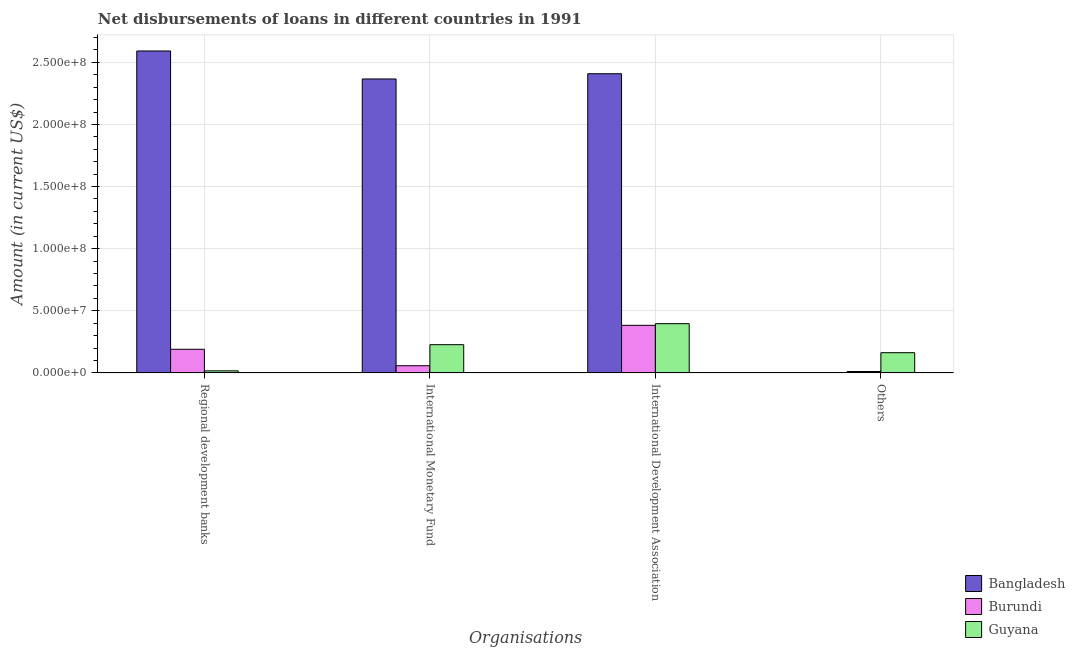Are the number of bars per tick equal to the number of legend labels?
Provide a succinct answer. No. How many bars are there on the 2nd tick from the left?
Provide a short and direct response. 3. How many bars are there on the 3rd tick from the right?
Ensure brevity in your answer.  3. What is the label of the 4th group of bars from the left?
Keep it short and to the point. Others. What is the amount of loan disimbursed by international development association in Bangladesh?
Make the answer very short. 2.41e+08. Across all countries, what is the maximum amount of loan disimbursed by international monetary fund?
Ensure brevity in your answer.  2.37e+08. Across all countries, what is the minimum amount of loan disimbursed by other organisations?
Give a very brief answer. 0. In which country was the amount of loan disimbursed by international monetary fund maximum?
Provide a short and direct response. Bangladesh. What is the total amount of loan disimbursed by regional development banks in the graph?
Provide a short and direct response. 2.80e+08. What is the difference between the amount of loan disimbursed by international development association in Bangladesh and that in Guyana?
Offer a very short reply. 2.01e+08. What is the difference between the amount of loan disimbursed by regional development banks in Guyana and the amount of loan disimbursed by other organisations in Burundi?
Keep it short and to the point. 5.36e+05. What is the average amount of loan disimbursed by other organisations per country?
Your answer should be compact. 5.78e+06. What is the difference between the amount of loan disimbursed by international development association and amount of loan disimbursed by other organisations in Burundi?
Your answer should be compact. 3.72e+07. In how many countries, is the amount of loan disimbursed by other organisations greater than 70000000 US$?
Offer a terse response. 0. What is the ratio of the amount of loan disimbursed by international development association in Bangladesh to that in Burundi?
Provide a short and direct response. 6.29. Is the amount of loan disimbursed by international development association in Burundi less than that in Bangladesh?
Give a very brief answer. Yes. Is the difference between the amount of loan disimbursed by regional development banks in Burundi and Guyana greater than the difference between the amount of loan disimbursed by international development association in Burundi and Guyana?
Your answer should be very brief. Yes. What is the difference between the highest and the second highest amount of loan disimbursed by international development association?
Ensure brevity in your answer.  2.01e+08. What is the difference between the highest and the lowest amount of loan disimbursed by other organisations?
Ensure brevity in your answer.  1.62e+07. In how many countries, is the amount of loan disimbursed by other organisations greater than the average amount of loan disimbursed by other organisations taken over all countries?
Give a very brief answer. 1. Is the sum of the amount of loan disimbursed by international development association in Guyana and Burundi greater than the maximum amount of loan disimbursed by other organisations across all countries?
Ensure brevity in your answer.  Yes. Is it the case that in every country, the sum of the amount of loan disimbursed by international development association and amount of loan disimbursed by international monetary fund is greater than the sum of amount of loan disimbursed by other organisations and amount of loan disimbursed by regional development banks?
Ensure brevity in your answer.  No. How many countries are there in the graph?
Offer a very short reply. 3. Are the values on the major ticks of Y-axis written in scientific E-notation?
Your answer should be very brief. Yes. Does the graph contain grids?
Give a very brief answer. Yes. How many legend labels are there?
Offer a terse response. 3. How are the legend labels stacked?
Offer a very short reply. Vertical. What is the title of the graph?
Keep it short and to the point. Net disbursements of loans in different countries in 1991. Does "Maldives" appear as one of the legend labels in the graph?
Your response must be concise. No. What is the label or title of the X-axis?
Offer a terse response. Organisations. What is the Amount (in current US$) in Bangladesh in Regional development banks?
Offer a very short reply. 2.59e+08. What is the Amount (in current US$) in Burundi in Regional development banks?
Keep it short and to the point. 1.90e+07. What is the Amount (in current US$) of Guyana in Regional development banks?
Offer a very short reply. 1.63e+06. What is the Amount (in current US$) of Bangladesh in International Monetary Fund?
Make the answer very short. 2.37e+08. What is the Amount (in current US$) of Burundi in International Monetary Fund?
Keep it short and to the point. 5.74e+06. What is the Amount (in current US$) of Guyana in International Monetary Fund?
Provide a short and direct response. 2.27e+07. What is the Amount (in current US$) in Bangladesh in International Development Association?
Your answer should be very brief. 2.41e+08. What is the Amount (in current US$) of Burundi in International Development Association?
Your response must be concise. 3.83e+07. What is the Amount (in current US$) of Guyana in International Development Association?
Your answer should be very brief. 3.96e+07. What is the Amount (in current US$) in Bangladesh in Others?
Provide a short and direct response. 0. What is the Amount (in current US$) in Burundi in Others?
Offer a terse response. 1.09e+06. What is the Amount (in current US$) in Guyana in Others?
Keep it short and to the point. 1.62e+07. Across all Organisations, what is the maximum Amount (in current US$) of Bangladesh?
Offer a terse response. 2.59e+08. Across all Organisations, what is the maximum Amount (in current US$) in Burundi?
Ensure brevity in your answer.  3.83e+07. Across all Organisations, what is the maximum Amount (in current US$) in Guyana?
Offer a very short reply. 3.96e+07. Across all Organisations, what is the minimum Amount (in current US$) in Bangladesh?
Offer a terse response. 0. Across all Organisations, what is the minimum Amount (in current US$) in Burundi?
Your answer should be very brief. 1.09e+06. Across all Organisations, what is the minimum Amount (in current US$) of Guyana?
Make the answer very short. 1.63e+06. What is the total Amount (in current US$) in Bangladesh in the graph?
Make the answer very short. 7.37e+08. What is the total Amount (in current US$) in Burundi in the graph?
Provide a succinct answer. 6.41e+07. What is the total Amount (in current US$) of Guyana in the graph?
Provide a short and direct response. 8.02e+07. What is the difference between the Amount (in current US$) of Bangladesh in Regional development banks and that in International Monetary Fund?
Your answer should be very brief. 2.25e+07. What is the difference between the Amount (in current US$) of Burundi in Regional development banks and that in International Monetary Fund?
Give a very brief answer. 1.32e+07. What is the difference between the Amount (in current US$) of Guyana in Regional development banks and that in International Monetary Fund?
Make the answer very short. -2.11e+07. What is the difference between the Amount (in current US$) in Bangladesh in Regional development banks and that in International Development Association?
Make the answer very short. 1.83e+07. What is the difference between the Amount (in current US$) of Burundi in Regional development banks and that in International Development Association?
Provide a succinct answer. -1.93e+07. What is the difference between the Amount (in current US$) in Guyana in Regional development banks and that in International Development Association?
Give a very brief answer. -3.80e+07. What is the difference between the Amount (in current US$) in Burundi in Regional development banks and that in Others?
Offer a very short reply. 1.79e+07. What is the difference between the Amount (in current US$) in Guyana in Regional development banks and that in Others?
Keep it short and to the point. -1.46e+07. What is the difference between the Amount (in current US$) of Bangladesh in International Monetary Fund and that in International Development Association?
Give a very brief answer. -4.22e+06. What is the difference between the Amount (in current US$) of Burundi in International Monetary Fund and that in International Development Association?
Ensure brevity in your answer.  -3.25e+07. What is the difference between the Amount (in current US$) of Guyana in International Monetary Fund and that in International Development Association?
Offer a terse response. -1.69e+07. What is the difference between the Amount (in current US$) of Burundi in International Monetary Fund and that in Others?
Provide a short and direct response. 4.65e+06. What is the difference between the Amount (in current US$) in Guyana in International Monetary Fund and that in Others?
Make the answer very short. 6.45e+06. What is the difference between the Amount (in current US$) of Burundi in International Development Association and that in Others?
Give a very brief answer. 3.72e+07. What is the difference between the Amount (in current US$) of Guyana in International Development Association and that in Others?
Provide a short and direct response. 2.34e+07. What is the difference between the Amount (in current US$) of Bangladesh in Regional development banks and the Amount (in current US$) of Burundi in International Monetary Fund?
Offer a very short reply. 2.53e+08. What is the difference between the Amount (in current US$) in Bangladesh in Regional development banks and the Amount (in current US$) in Guyana in International Monetary Fund?
Make the answer very short. 2.36e+08. What is the difference between the Amount (in current US$) of Burundi in Regional development banks and the Amount (in current US$) of Guyana in International Monetary Fund?
Your answer should be compact. -3.71e+06. What is the difference between the Amount (in current US$) of Bangladesh in Regional development banks and the Amount (in current US$) of Burundi in International Development Association?
Offer a very short reply. 2.21e+08. What is the difference between the Amount (in current US$) of Bangladesh in Regional development banks and the Amount (in current US$) of Guyana in International Development Association?
Your answer should be compact. 2.20e+08. What is the difference between the Amount (in current US$) of Burundi in Regional development banks and the Amount (in current US$) of Guyana in International Development Association?
Offer a very short reply. -2.06e+07. What is the difference between the Amount (in current US$) of Bangladesh in Regional development banks and the Amount (in current US$) of Burundi in Others?
Provide a short and direct response. 2.58e+08. What is the difference between the Amount (in current US$) of Bangladesh in Regional development banks and the Amount (in current US$) of Guyana in Others?
Your response must be concise. 2.43e+08. What is the difference between the Amount (in current US$) in Burundi in Regional development banks and the Amount (in current US$) in Guyana in Others?
Your answer should be very brief. 2.75e+06. What is the difference between the Amount (in current US$) in Bangladesh in International Monetary Fund and the Amount (in current US$) in Burundi in International Development Association?
Keep it short and to the point. 1.98e+08. What is the difference between the Amount (in current US$) of Bangladesh in International Monetary Fund and the Amount (in current US$) of Guyana in International Development Association?
Your answer should be compact. 1.97e+08. What is the difference between the Amount (in current US$) in Burundi in International Monetary Fund and the Amount (in current US$) in Guyana in International Development Association?
Provide a short and direct response. -3.39e+07. What is the difference between the Amount (in current US$) of Bangladesh in International Monetary Fund and the Amount (in current US$) of Burundi in Others?
Your response must be concise. 2.36e+08. What is the difference between the Amount (in current US$) in Bangladesh in International Monetary Fund and the Amount (in current US$) in Guyana in Others?
Ensure brevity in your answer.  2.20e+08. What is the difference between the Amount (in current US$) in Burundi in International Monetary Fund and the Amount (in current US$) in Guyana in Others?
Offer a terse response. -1.05e+07. What is the difference between the Amount (in current US$) of Bangladesh in International Development Association and the Amount (in current US$) of Burundi in Others?
Make the answer very short. 2.40e+08. What is the difference between the Amount (in current US$) of Bangladesh in International Development Association and the Amount (in current US$) of Guyana in Others?
Make the answer very short. 2.25e+08. What is the difference between the Amount (in current US$) in Burundi in International Development Association and the Amount (in current US$) in Guyana in Others?
Offer a terse response. 2.20e+07. What is the average Amount (in current US$) in Bangladesh per Organisations?
Offer a very short reply. 1.84e+08. What is the average Amount (in current US$) in Burundi per Organisations?
Offer a very short reply. 1.60e+07. What is the average Amount (in current US$) in Guyana per Organisations?
Offer a very short reply. 2.00e+07. What is the difference between the Amount (in current US$) in Bangladesh and Amount (in current US$) in Burundi in Regional development banks?
Provide a succinct answer. 2.40e+08. What is the difference between the Amount (in current US$) in Bangladesh and Amount (in current US$) in Guyana in Regional development banks?
Your answer should be very brief. 2.58e+08. What is the difference between the Amount (in current US$) in Burundi and Amount (in current US$) in Guyana in Regional development banks?
Your response must be concise. 1.74e+07. What is the difference between the Amount (in current US$) of Bangladesh and Amount (in current US$) of Burundi in International Monetary Fund?
Your answer should be compact. 2.31e+08. What is the difference between the Amount (in current US$) of Bangladesh and Amount (in current US$) of Guyana in International Monetary Fund?
Keep it short and to the point. 2.14e+08. What is the difference between the Amount (in current US$) of Burundi and Amount (in current US$) of Guyana in International Monetary Fund?
Provide a succinct answer. -1.70e+07. What is the difference between the Amount (in current US$) of Bangladesh and Amount (in current US$) of Burundi in International Development Association?
Your response must be concise. 2.03e+08. What is the difference between the Amount (in current US$) of Bangladesh and Amount (in current US$) of Guyana in International Development Association?
Offer a terse response. 2.01e+08. What is the difference between the Amount (in current US$) in Burundi and Amount (in current US$) in Guyana in International Development Association?
Your response must be concise. -1.35e+06. What is the difference between the Amount (in current US$) in Burundi and Amount (in current US$) in Guyana in Others?
Your answer should be compact. -1.52e+07. What is the ratio of the Amount (in current US$) in Bangladesh in Regional development banks to that in International Monetary Fund?
Offer a very short reply. 1.1. What is the ratio of the Amount (in current US$) in Burundi in Regional development banks to that in International Monetary Fund?
Offer a very short reply. 3.31. What is the ratio of the Amount (in current US$) of Guyana in Regional development banks to that in International Monetary Fund?
Your answer should be very brief. 0.07. What is the ratio of the Amount (in current US$) of Bangladesh in Regional development banks to that in International Development Association?
Your response must be concise. 1.08. What is the ratio of the Amount (in current US$) of Burundi in Regional development banks to that in International Development Association?
Ensure brevity in your answer.  0.5. What is the ratio of the Amount (in current US$) in Guyana in Regional development banks to that in International Development Association?
Keep it short and to the point. 0.04. What is the ratio of the Amount (in current US$) in Burundi in Regional development banks to that in Others?
Provide a succinct answer. 17.39. What is the ratio of the Amount (in current US$) of Guyana in Regional development banks to that in Others?
Ensure brevity in your answer.  0.1. What is the ratio of the Amount (in current US$) of Bangladesh in International Monetary Fund to that in International Development Association?
Your response must be concise. 0.98. What is the ratio of the Amount (in current US$) in Burundi in International Monetary Fund to that in International Development Association?
Your answer should be compact. 0.15. What is the ratio of the Amount (in current US$) of Guyana in International Monetary Fund to that in International Development Association?
Make the answer very short. 0.57. What is the ratio of the Amount (in current US$) in Burundi in International Monetary Fund to that in Others?
Your answer should be very brief. 5.26. What is the ratio of the Amount (in current US$) in Guyana in International Monetary Fund to that in Others?
Your answer should be compact. 1.4. What is the ratio of the Amount (in current US$) in Burundi in International Development Association to that in Others?
Keep it short and to the point. 35.04. What is the ratio of the Amount (in current US$) of Guyana in International Development Association to that in Others?
Offer a terse response. 2.44. What is the difference between the highest and the second highest Amount (in current US$) in Bangladesh?
Offer a terse response. 1.83e+07. What is the difference between the highest and the second highest Amount (in current US$) of Burundi?
Give a very brief answer. 1.93e+07. What is the difference between the highest and the second highest Amount (in current US$) of Guyana?
Your answer should be very brief. 1.69e+07. What is the difference between the highest and the lowest Amount (in current US$) in Bangladesh?
Make the answer very short. 2.59e+08. What is the difference between the highest and the lowest Amount (in current US$) of Burundi?
Your response must be concise. 3.72e+07. What is the difference between the highest and the lowest Amount (in current US$) in Guyana?
Make the answer very short. 3.80e+07. 